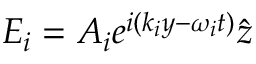<formula> <loc_0><loc_0><loc_500><loc_500>E _ { i } = A _ { i } e ^ { i ( k _ { i } y - \omega _ { i } t ) } \hat { z }</formula> 